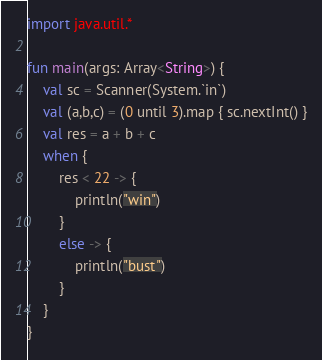<code> <loc_0><loc_0><loc_500><loc_500><_Kotlin_>import java.util.*

fun main(args: Array<String>) {
    val sc = Scanner(System.`in`)
    val (a,b,c) = (0 until 3).map { sc.nextInt() }
    val res = a + b + c
    when {
        res < 22 -> {
            println("win")
        }
        else -> {
            println("bust")
        }
    }
}</code> 